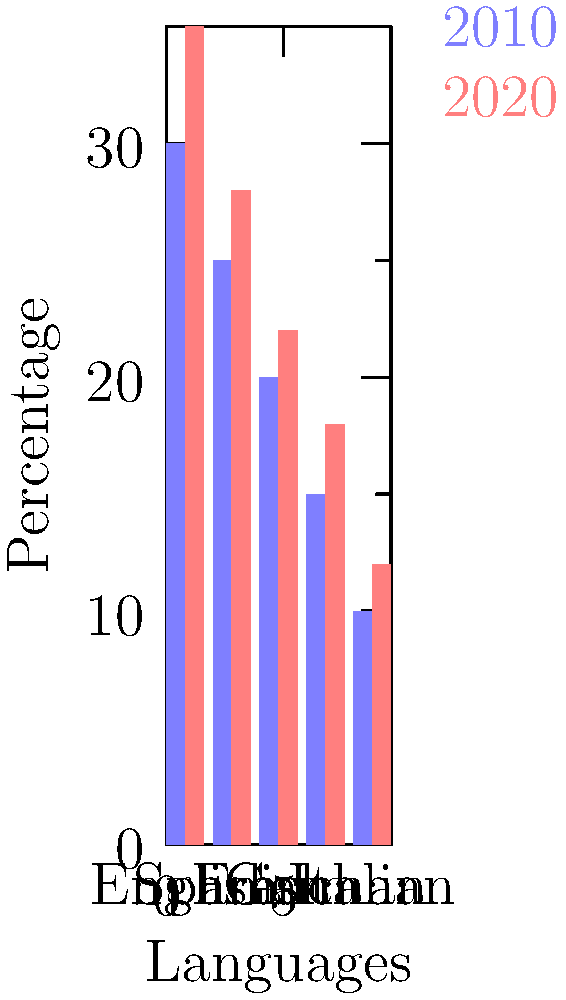Based on the bar chart comparing language popularity trends between 2010 and 2020, which language showed the largest percentage increase in popularity? To determine which language had the largest percentage increase in popularity, we need to calculate the percentage change for each language and compare:

1. English:
   2010: 30%, 2020: 35%
   Percentage increase = $(35 - 30) / 30 \times 100\% = 16.67\%$

2. Spanish:
   2010: 25%, 2020: 28%
   Percentage increase = $(28 - 25) / 25 \times 100\% = 12\%$

3. French:
   2010: 20%, 2020: 22%
   Percentage increase = $(22 - 20) / 20 \times 100\% = 10\%$

4. German:
   2010: 15%, 2020: 18%
   Percentage increase = $(18 - 15) / 15 \times 100\% = 20\%$

5. Italian:
   2010: 10%, 2020: 12%
   Percentage increase = $(12 - 10) / 10 \times 100\% = 20\%$

Comparing the percentage increases, we can see that German and Italian both had the largest increase at 20%.
Answer: German and Italian (tie at 20% increase) 